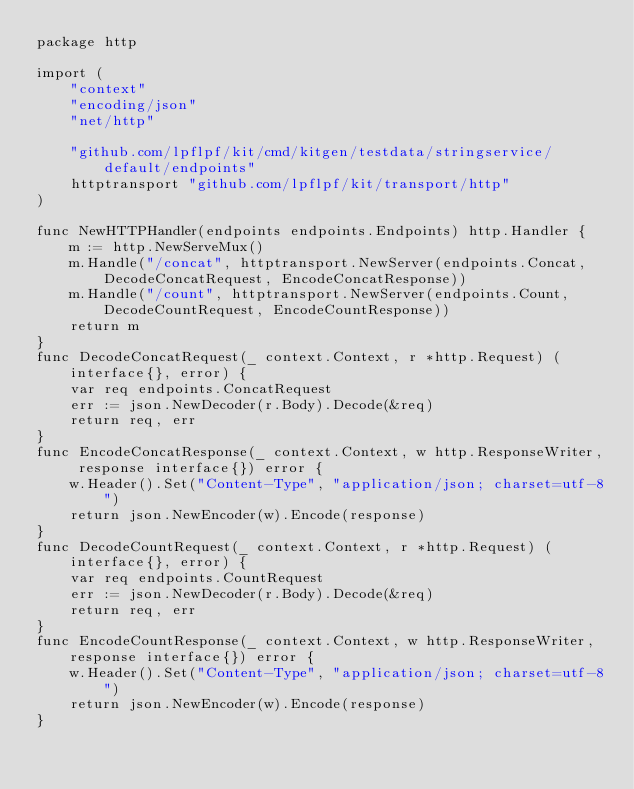<code> <loc_0><loc_0><loc_500><loc_500><_Go_>package http

import (
	"context"
	"encoding/json"
	"net/http"

	"github.com/lpflpf/kit/cmd/kitgen/testdata/stringservice/default/endpoints"
	httptransport "github.com/lpflpf/kit/transport/http"
)

func NewHTTPHandler(endpoints endpoints.Endpoints) http.Handler {
	m := http.NewServeMux()
	m.Handle("/concat", httptransport.NewServer(endpoints.Concat, DecodeConcatRequest, EncodeConcatResponse))
	m.Handle("/count", httptransport.NewServer(endpoints.Count, DecodeCountRequest, EncodeCountResponse))
	return m
}
func DecodeConcatRequest(_ context.Context, r *http.Request) (interface{}, error) {
	var req endpoints.ConcatRequest
	err := json.NewDecoder(r.Body).Decode(&req)
	return req, err
}
func EncodeConcatResponse(_ context.Context, w http.ResponseWriter, response interface{}) error {
	w.Header().Set("Content-Type", "application/json; charset=utf-8")
	return json.NewEncoder(w).Encode(response)
}
func DecodeCountRequest(_ context.Context, r *http.Request) (interface{}, error) {
	var req endpoints.CountRequest
	err := json.NewDecoder(r.Body).Decode(&req)
	return req, err
}
func EncodeCountResponse(_ context.Context, w http.ResponseWriter, response interface{}) error {
	w.Header().Set("Content-Type", "application/json; charset=utf-8")
	return json.NewEncoder(w).Encode(response)
}
</code> 